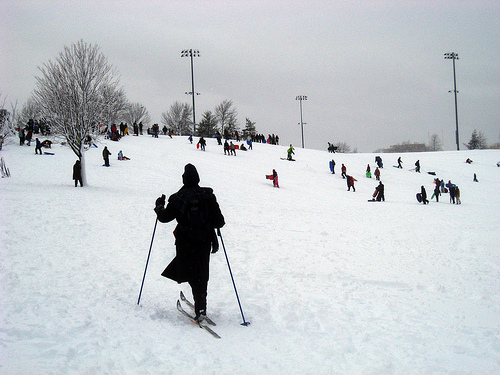Please provide the bounding box coordinate of the region this sentence describes: a black ski pole. [0.26, 0.5, 0.34, 0.74] effectively covers the area where the black ski pole is visible. 